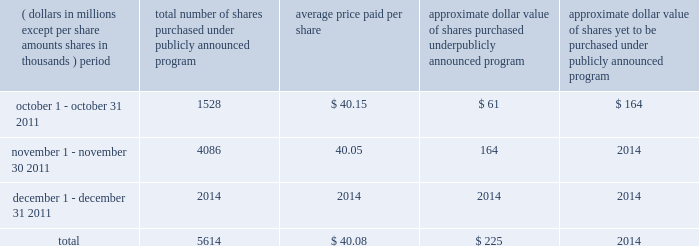In march 2011 , we announced a new program under which the purchase by us of up to $ 675 million of our common stock in 2011 was authorized by our board of directors .
During 2011 , we purchased approximately 16.3 million shares of our common stock under this program , and as of december 31 , 2011 , no purchase authority remained under the program .
The table presents purchases of our common stock and related information for the three months ended december 31 , 2011 .
( dollars in millions , except per share amounts , shares in thousands ) period total number of shares purchased under publicly announced program average price paid per share approximate dollar value of shares purchased under publicly announced program approximate dollar value of shares yet to be purchased under publicly announced program .
Additional information about our common stock , including board of directors authorization with respect to purchases by us of our common stock , is provided under 201ccapital-regulatory capital 201d in management 2019s discussion and analysis , included under item 7 , and in note 12 to the consolidated financial statements included under item 8 , and is incorporated herein by reference .
Related stockholdermatters as a bank holding company , the parent company is a legal entity separate and distinct from its principal banking subsidiary , state street bank , and its non-banking subsidiaries .
The right of the parent company to participate as a shareholder in any distribution of assets of state street bank upon its liquidation , reorganization or otherwise is subject to the prior claims by creditors of state street bank , including obligations for federal funds purchased and securities sold under repurchase agreements and deposit liabilities .
Payment of common stock dividends by state street bank is subject to the provisions of massachusetts banking law , which provide that dividends may be paid out of net profits provided ( i ) capital stock and surplus remain unimpaired , ( ii ) dividend and retirement fund requirements of any preferred stock have been met , ( iii ) surplus equals or exceeds capital stock , and ( iv ) losses and bad debts , as defined , in excess of reserves specifically established for such losses and bad debts , have been deducted from net profits .
Under the federal reserve act and massachusetts state law , regulatory approval of the federal reserve and the massachusetts division of banks would be required if dividends declared by state street bank in any year exceeded the total of its net profits for that year combined with its retained net profits for the preceding two years , less any required transfers to surplus .
In 2011 , the parent company declared aggregate common stock dividends of $ 0.72 per share , or approximately $ 358 million .
In 2010 , the parent company declared aggregate common stock dividends of $ 0.04 per share , or $ 20 million .
The 2011 common stock dividends represented the first increase in our common stock dividend since we announced a reduction of such dividends in the first quarter of 2009 .
The prior approval of the federal reserve is required for us to pay future common stock dividends .
Information about dividends from the parent company and from our subsidiary banks is provided under 201ccapital 2014regulatory capital 201d in management 2019s discussion and analysis , included under item 7 , and in note 15 to the consolidated financial statements included under item 8 , and is incorporated herein by reference .
Future dividend payments of state street bank and other non-banking subsidiaries cannot be determined at this time .
As of december 31 , 2011 , the parent company had $ 500 million outstanding in aggregate liquidation preference of its series a preferred stock .
Holders of shares of the preferred stock are entitled to receive non- cumulative cash dividends , only when , as and if declared by the parent company 2019s board of directors .
Any dividends on the preferred stock are calculated at a rate per annum equal to the three-month libor for the relevant three-month period plus 4.99% ( 4.99 % ) , with such dividend rate applied to the outstanding liquidation preference .
What was the percent of the total number of shares purchased under publicly announced program in november? 
Computations: (4086 / 5614)
Answer: 0.72782. 